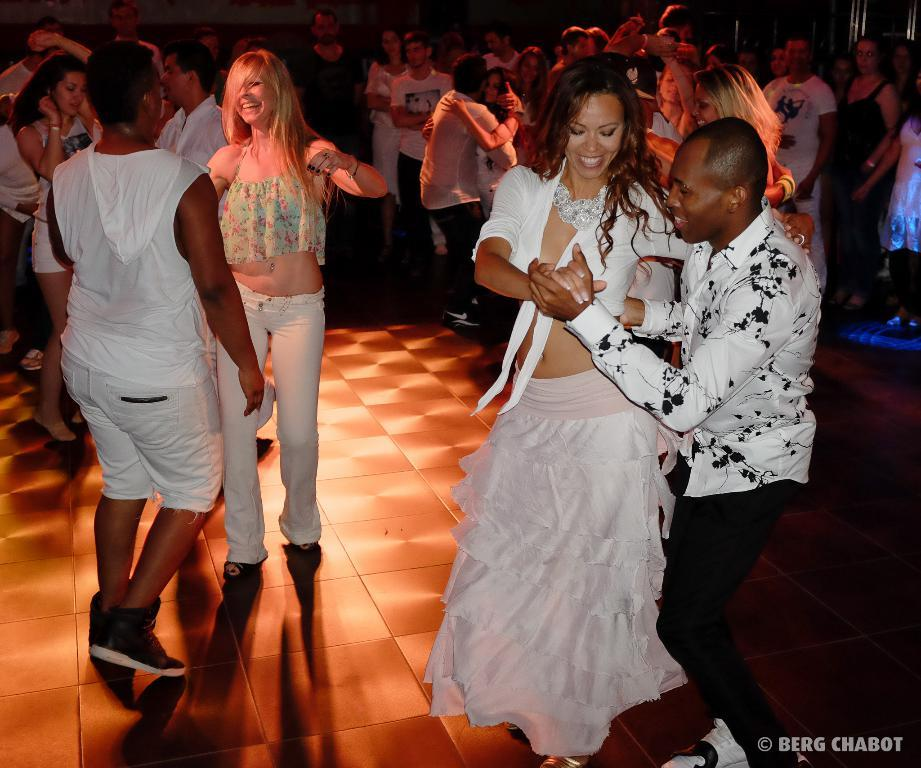How many people are in the image? There is a group of persons in the image. What are some of the persons doing in the image? Some of the persons are dancing in the foreground. What time does the clock in the image show? There is no clock present in the image. How can you tell if the actor in the image is performing well? There is no actor or performance mentioned in the image; it only shows a group of persons, some of whom are dancing. 